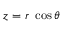<formula> <loc_0><loc_0><loc_500><loc_500>z = r \cos \theta</formula> 